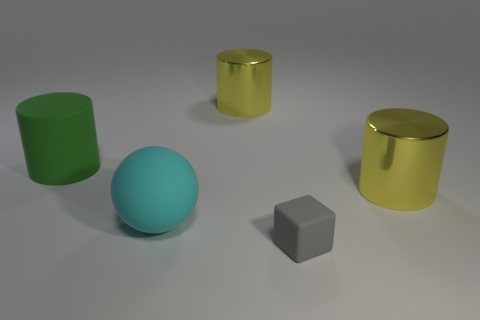Add 2 metallic objects. How many objects exist? 7 Subtract all cubes. How many objects are left? 4 Add 2 tiny matte things. How many tiny matte things exist? 3 Subtract 0 blue cylinders. How many objects are left? 5 Subtract all small brown balls. Subtract all large cyan matte objects. How many objects are left? 4 Add 5 green cylinders. How many green cylinders are left? 6 